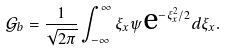<formula> <loc_0><loc_0><loc_500><loc_500>\mathcal { G } _ { b } = \frac { 1 } { \sqrt { 2 \pi } } \int ^ { \infty } _ { - \infty } \xi _ { x } \psi \text {e} ^ { - \xi _ { x } ^ { 2 } / 2 } d \xi _ { x } .</formula> 